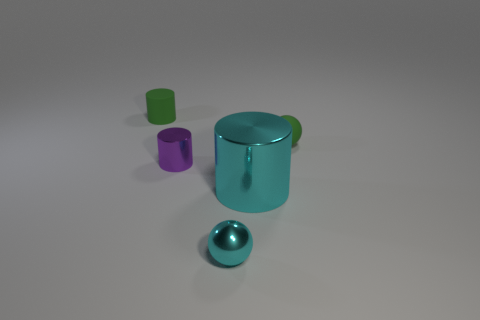Do the large metal cylinder and the metal ball have the same color?
Give a very brief answer. Yes. Is there any other thing that has the same size as the cyan metal cylinder?
Provide a succinct answer. No. There is a purple object; does it have the same shape as the thing left of the small purple metal thing?
Your response must be concise. Yes. The tiny rubber object that is to the left of the cylinder on the right side of the tiny metal object that is behind the cyan sphere is what color?
Keep it short and to the point. Green. What number of things are green objects that are to the left of the large cyan metallic object or cyan objects that are in front of the large thing?
Ensure brevity in your answer.  2. How many other things are there of the same color as the rubber cylinder?
Provide a succinct answer. 1. Is the shape of the green object behind the green matte ball the same as  the purple thing?
Your answer should be very brief. Yes. Are there fewer small green rubber cylinders that are right of the small cyan metallic sphere than tiny gray metal blocks?
Provide a succinct answer. No. Is there a small brown object that has the same material as the purple thing?
Ensure brevity in your answer.  No. There is a purple cylinder that is the same size as the cyan shiny sphere; what is it made of?
Provide a succinct answer. Metal. 